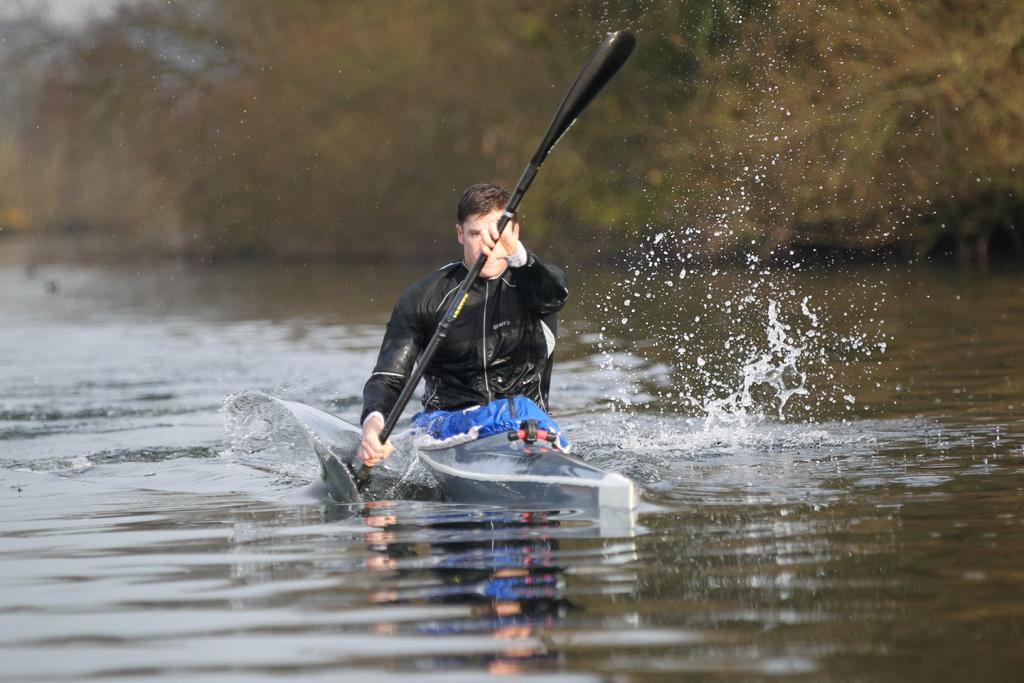Who is present in the image? There is a person in the image. What is the person wearing? The person is wearing a black color jacket. What is the person doing in the image? The person is sitting in a boat and holding an oar in their hands. What is the boat doing in the image? The boat is sailing on water. What can be seen in the background of the image? There are trees in the background of the image. How does the person sort the fish they catch in the image? There is no fishing activity depicted in the image; the person is holding an oar and sailing in a boat. 